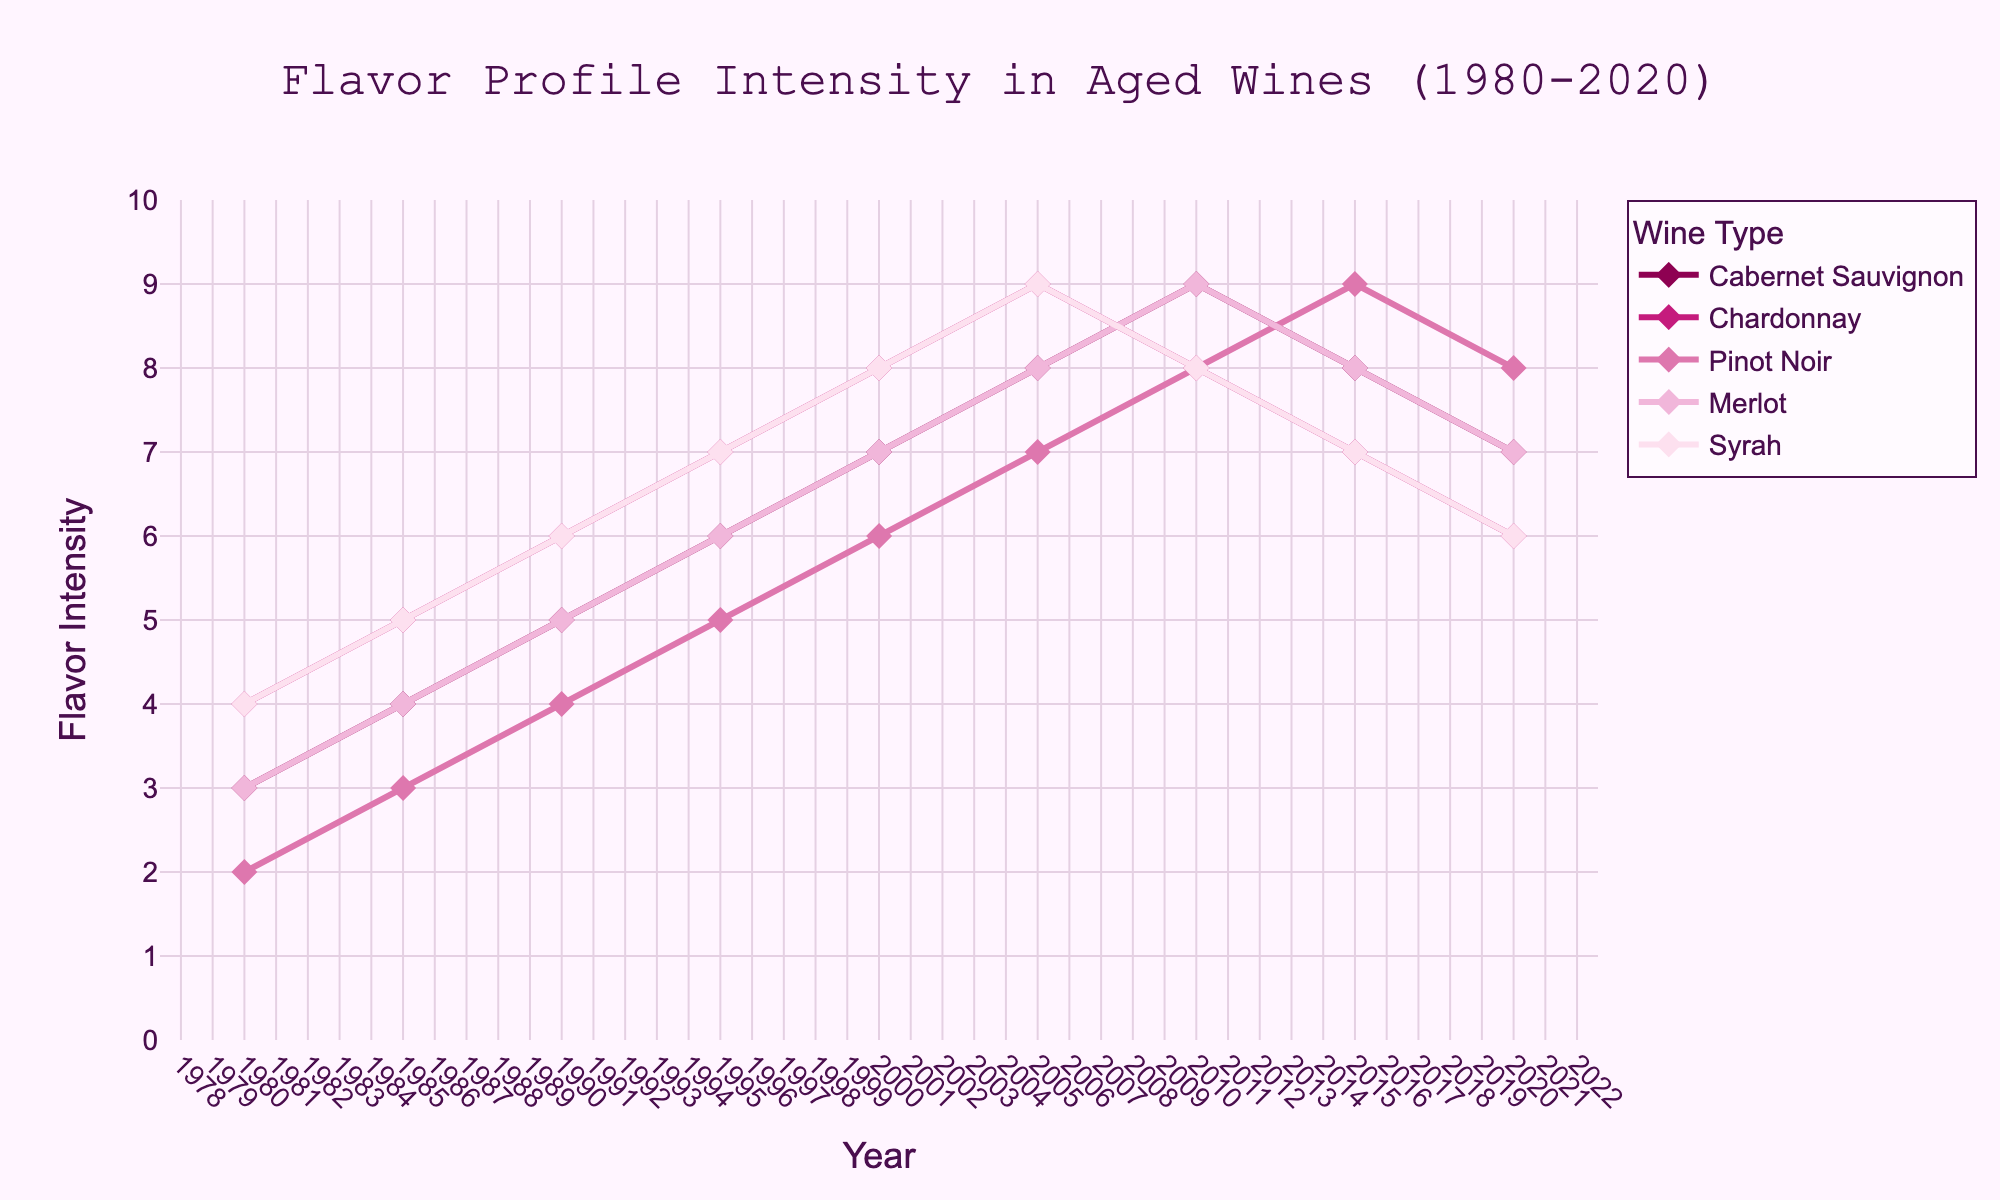What's the title of the figure? The title is usually placed at the top of the figure and it summarizes the main topic or findings represented.
Answer: Flavor Profile Intensity in Aged Wines (1980-2020) What are the years presented on the x-axis? The x-axis displays the years at regular intervals. By looking along the x-axis, one can see the range and specific years presented.
Answer: 1980, 1985, 1990, 1995, 2000, 2005, 2010, 2015, 2020 Which wine shows the most fluctuation in flavor profile intensity? To determine fluctuation, look at the lines representing each wine. The one with the most ups and downs has the most fluctuation.
Answer: Pinot Noir How did the flavor intensity of Merlot change from 1980 to 2020? Locate the Merlot line and compare the starting point (1980) with the endpoint (2020) to see the change.
Answer: Increased from 3 to 7 Which wine had the highest flavor intensity in 2005? Identify the data points on the lines for 2005 and find the highest value among them.
Answer: Cabernet Sauvignon What's the average flavor intensity of Syrah across all years? Add the flavor intensity values for Syrah across all years and divide by the number of years to find the average (4+5+6+7+8+9+8+7+6)/9.
Answer: 6.67 Which wine experienced a decrease in flavor intensity from 2010 to 2015? Locate the data points on the lines for 2010 and 2015, and find which one has a lower value in 2015 compared to 2010.
Answer: Chardonnay In which year did Pinot Noir have its highest flavor intensity? Trace the Pinot Noir line to find the highest point and then identify the corresponding year on the x-axis.
Answer: 2015 Between 1995 and 2000, which wine had the smallest increase in flavor intensity? Calculate the increase in flavor intensity for each wine between 1995 and 2000 (subtract 1995 value from 2000 value) and find the one with the smallest value.
Answer: All wines increased by 1 unit Which wines had a peak flavor intensity in 2010? Check the data points for 2010 and see which wines had their highest values in that year.
Answer: Pinot Noir, Merlot 